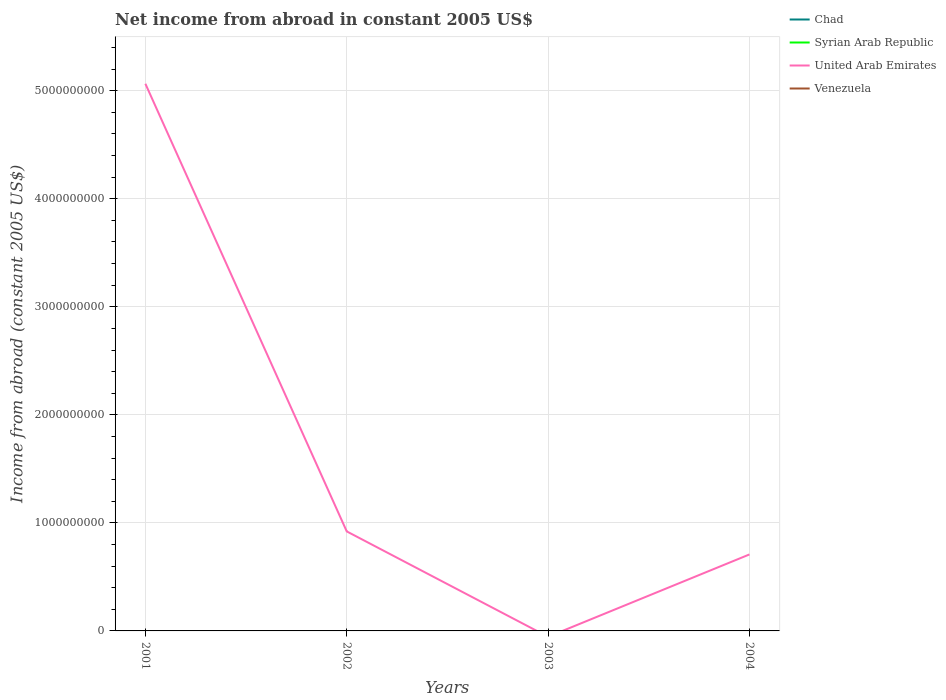What is the difference between the highest and the second highest net income from abroad in United Arab Emirates?
Make the answer very short. 5.06e+09. Is the net income from abroad in Venezuela strictly greater than the net income from abroad in United Arab Emirates over the years?
Provide a succinct answer. Yes. Are the values on the major ticks of Y-axis written in scientific E-notation?
Your response must be concise. No. Does the graph contain any zero values?
Ensure brevity in your answer.  Yes. How are the legend labels stacked?
Ensure brevity in your answer.  Vertical. What is the title of the graph?
Provide a short and direct response. Net income from abroad in constant 2005 US$. What is the label or title of the X-axis?
Provide a short and direct response. Years. What is the label or title of the Y-axis?
Your response must be concise. Income from abroad (constant 2005 US$). What is the Income from abroad (constant 2005 US$) in Chad in 2001?
Ensure brevity in your answer.  0. What is the Income from abroad (constant 2005 US$) in Syrian Arab Republic in 2001?
Your answer should be very brief. 0. What is the Income from abroad (constant 2005 US$) in United Arab Emirates in 2001?
Your answer should be compact. 5.06e+09. What is the Income from abroad (constant 2005 US$) of Chad in 2002?
Make the answer very short. 0. What is the Income from abroad (constant 2005 US$) in United Arab Emirates in 2002?
Offer a terse response. 9.21e+08. What is the Income from abroad (constant 2005 US$) in United Arab Emirates in 2003?
Keep it short and to the point. 0. What is the Income from abroad (constant 2005 US$) of Venezuela in 2003?
Provide a short and direct response. 0. What is the Income from abroad (constant 2005 US$) in Chad in 2004?
Provide a succinct answer. 0. What is the Income from abroad (constant 2005 US$) in United Arab Emirates in 2004?
Keep it short and to the point. 7.08e+08. Across all years, what is the maximum Income from abroad (constant 2005 US$) of United Arab Emirates?
Your response must be concise. 5.06e+09. Across all years, what is the minimum Income from abroad (constant 2005 US$) of United Arab Emirates?
Offer a very short reply. 0. What is the total Income from abroad (constant 2005 US$) of Syrian Arab Republic in the graph?
Ensure brevity in your answer.  0. What is the total Income from abroad (constant 2005 US$) of United Arab Emirates in the graph?
Your response must be concise. 6.69e+09. What is the total Income from abroad (constant 2005 US$) in Venezuela in the graph?
Offer a very short reply. 0. What is the difference between the Income from abroad (constant 2005 US$) in United Arab Emirates in 2001 and that in 2002?
Your answer should be very brief. 4.14e+09. What is the difference between the Income from abroad (constant 2005 US$) in United Arab Emirates in 2001 and that in 2004?
Your answer should be compact. 4.36e+09. What is the difference between the Income from abroad (constant 2005 US$) in United Arab Emirates in 2002 and that in 2004?
Keep it short and to the point. 2.13e+08. What is the average Income from abroad (constant 2005 US$) of United Arab Emirates per year?
Make the answer very short. 1.67e+09. What is the average Income from abroad (constant 2005 US$) in Venezuela per year?
Make the answer very short. 0. What is the ratio of the Income from abroad (constant 2005 US$) in United Arab Emirates in 2001 to that in 2002?
Make the answer very short. 5.5. What is the ratio of the Income from abroad (constant 2005 US$) in United Arab Emirates in 2001 to that in 2004?
Make the answer very short. 7.15. What is the ratio of the Income from abroad (constant 2005 US$) in United Arab Emirates in 2002 to that in 2004?
Provide a short and direct response. 1.3. What is the difference between the highest and the second highest Income from abroad (constant 2005 US$) in United Arab Emirates?
Ensure brevity in your answer.  4.14e+09. What is the difference between the highest and the lowest Income from abroad (constant 2005 US$) in United Arab Emirates?
Give a very brief answer. 5.06e+09. 